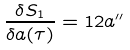<formula> <loc_0><loc_0><loc_500><loc_500>\frac { \delta S _ { 1 } } { \delta a ( \tau ) } = 1 2 a ^ { \prime \prime }</formula> 